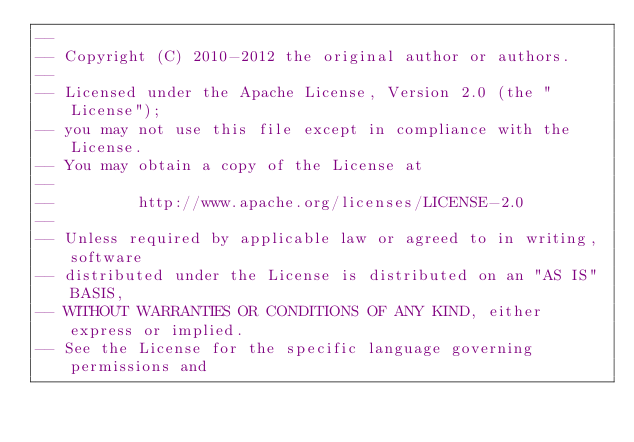<code> <loc_0><loc_0><loc_500><loc_500><_SQL_>--
-- Copyright (C) 2010-2012 the original author or authors.
--
-- Licensed under the Apache License, Version 2.0 (the "License");
-- you may not use this file except in compliance with the License.
-- You may obtain a copy of the License at
--
--         http://www.apache.org/licenses/LICENSE-2.0
--
-- Unless required by applicable law or agreed to in writing, software
-- distributed under the License is distributed on an "AS IS" BASIS,
-- WITHOUT WARRANTIES OR CONDITIONS OF ANY KIND, either express or implied.
-- See the License for the specific language governing permissions and</code> 